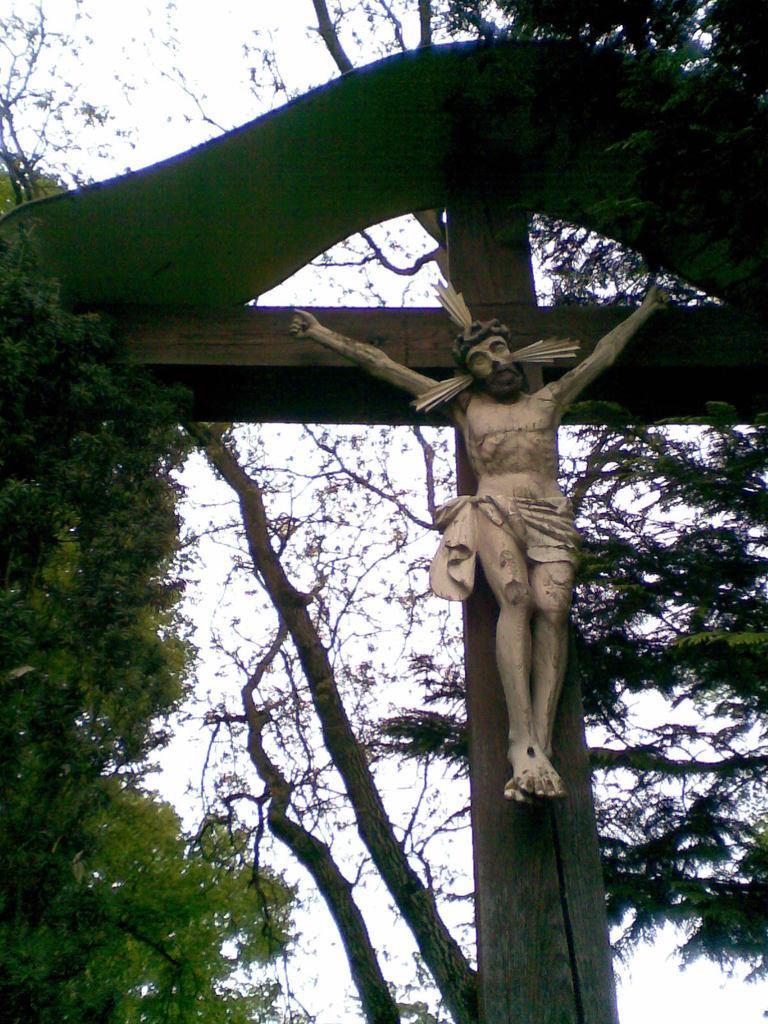Describe this image in one or two sentences. In this image there is a cross and statue and there are some trees, and in the background there is sky. 